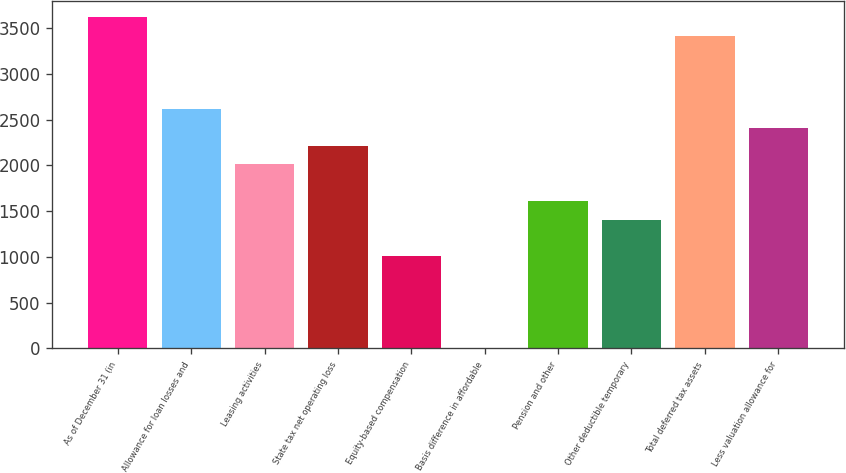Convert chart. <chart><loc_0><loc_0><loc_500><loc_500><bar_chart><fcel>As of December 31 (in<fcel>Allowance for loan losses and<fcel>Leasing activities<fcel>State tax net operating loss<fcel>Equity-based compensation<fcel>Basis difference in affordable<fcel>Pension and other<fcel>Other deductible temporary<fcel>Total deferred tax assets<fcel>Less valuation allowance for<nl><fcel>3619.2<fcel>2614.7<fcel>2012<fcel>2212.9<fcel>1007.5<fcel>3<fcel>1610.2<fcel>1409.3<fcel>3418.3<fcel>2413.8<nl></chart> 